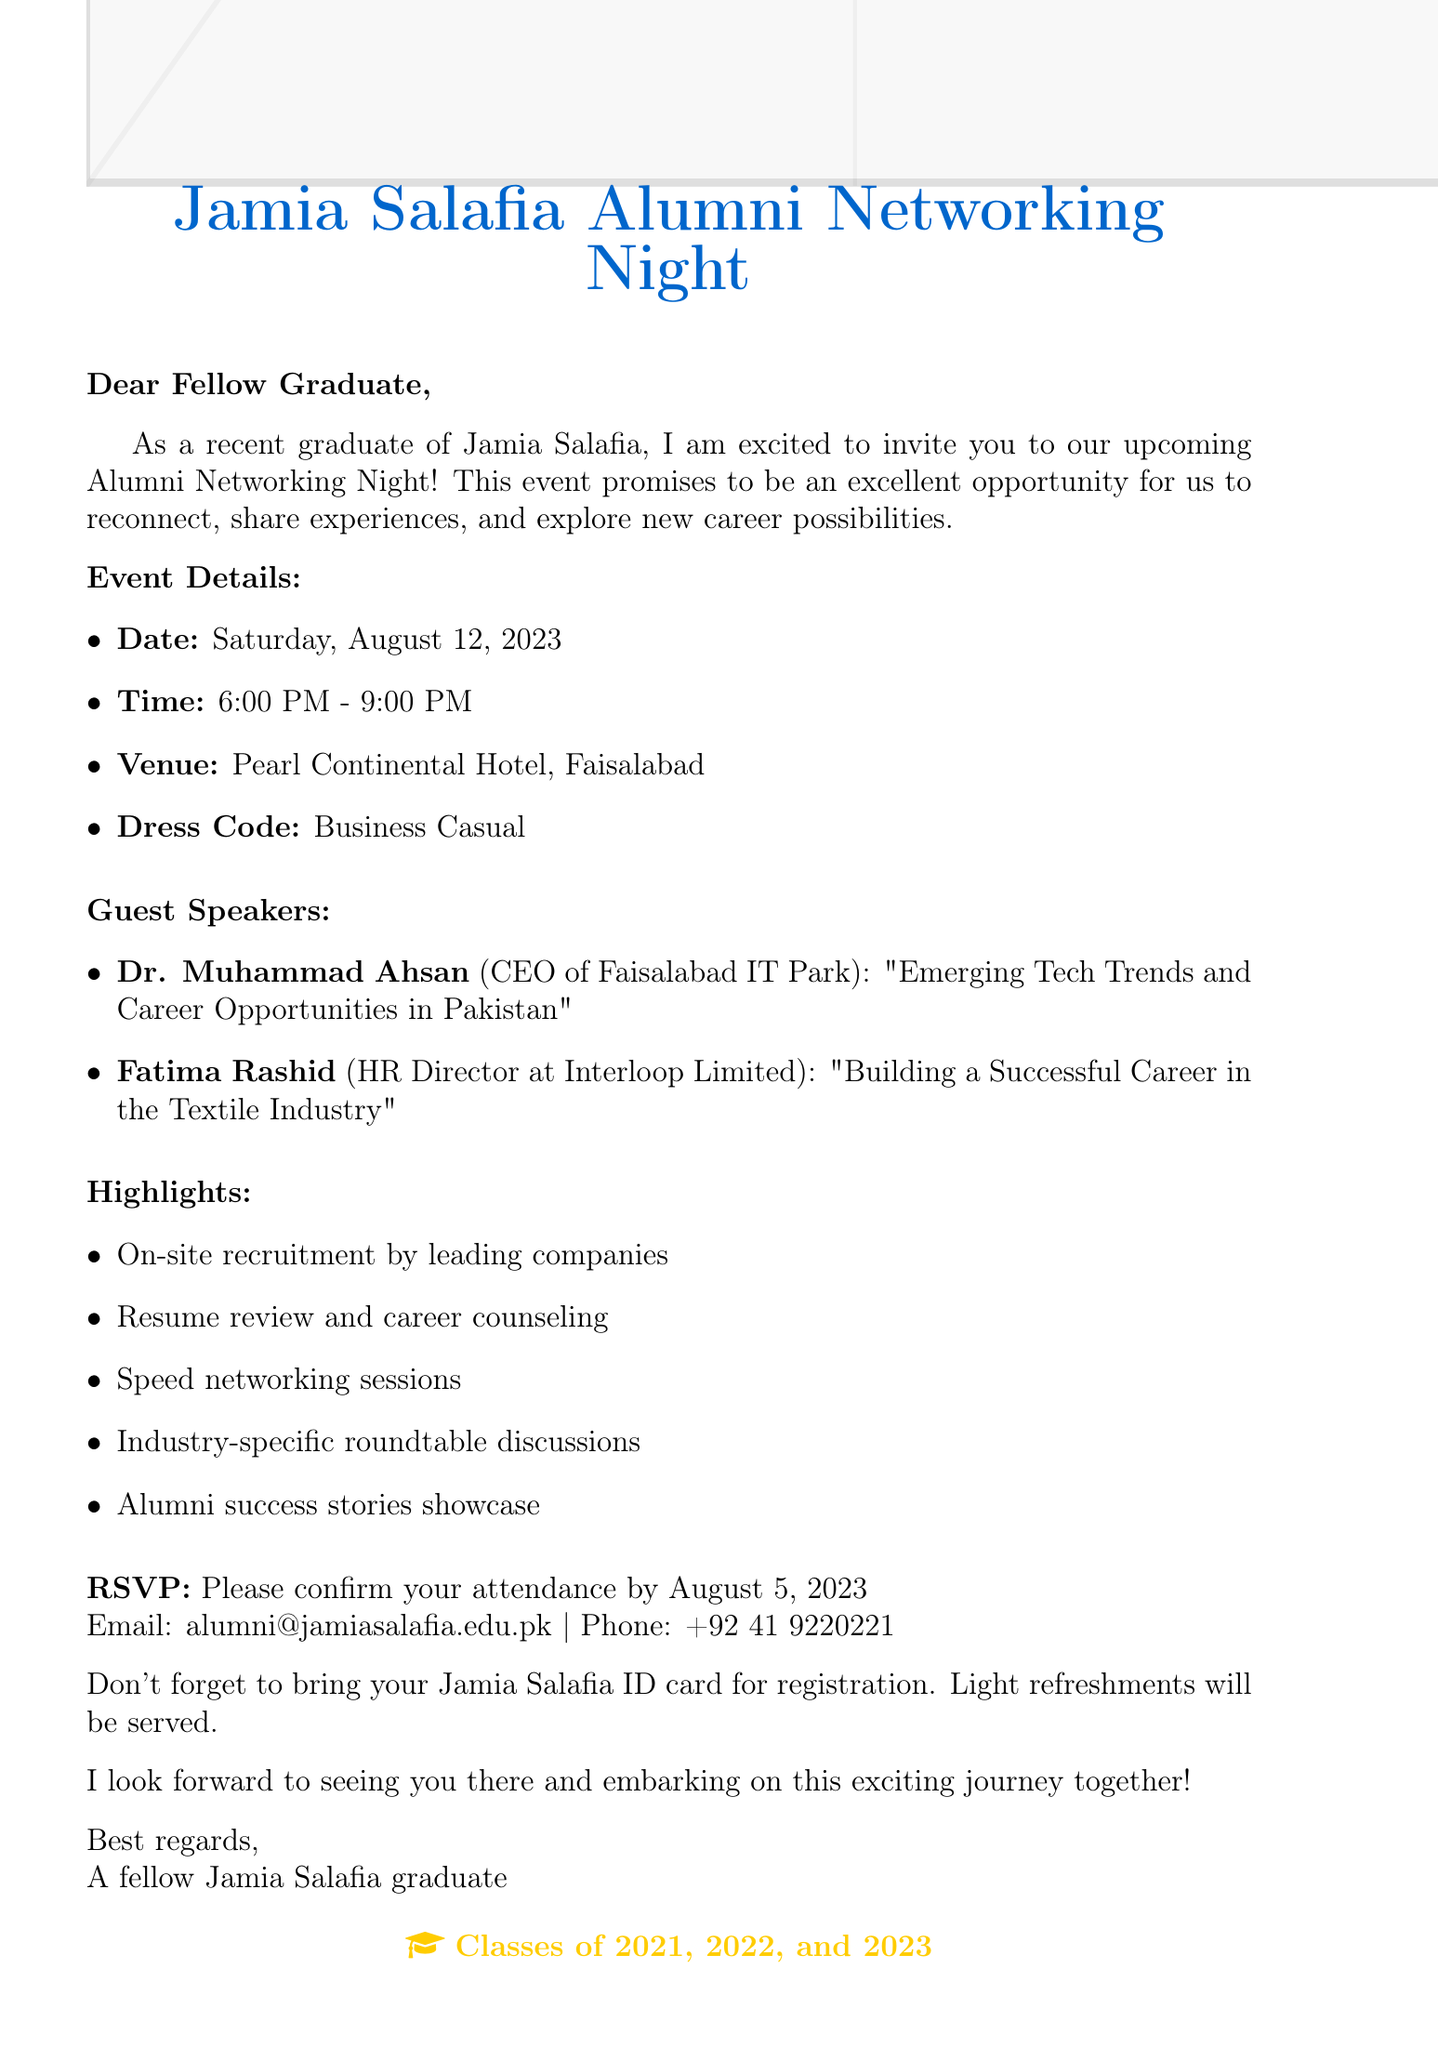What is the name of the event? The name of the event is provided in the document as "Jamia Salafia Alumni Networking Night".
Answer: Jamia Salafia Alumni Networking Night When is the event scheduled? The date of the event is explicitly mentioned in the document as "Saturday, August 12, 2023".
Answer: August 12, 2023 Who is one of the guest speakers? The document lists two guest speakers; one of them is "Dr. Muhammad Ahsan".
Answer: Dr. Muhammad Ahsan What is the dress code for the event? The dress code is specified in the document as "Business Casual".
Answer: Business Casual What career opportunity is included in the highlights? The document lists several opportunities, one of which is "On-site recruitment by leading companies in Faisalabad".
Answer: On-site recruitment by leading companies in Faisalabad What time does the event start? The starting time for the event is clearly indicated in the document as "6:00 PM".
Answer: 6:00 PM What is the RSVP deadline? The deadline for confirming attendance is provided in the document as "August 5, 2023".
Answer: August 5, 2023 What should attendees bring for registration? According to the document, attendees are requested to bring their "Jamia Salafia ID card".
Answer: Jamia Salafia ID card 